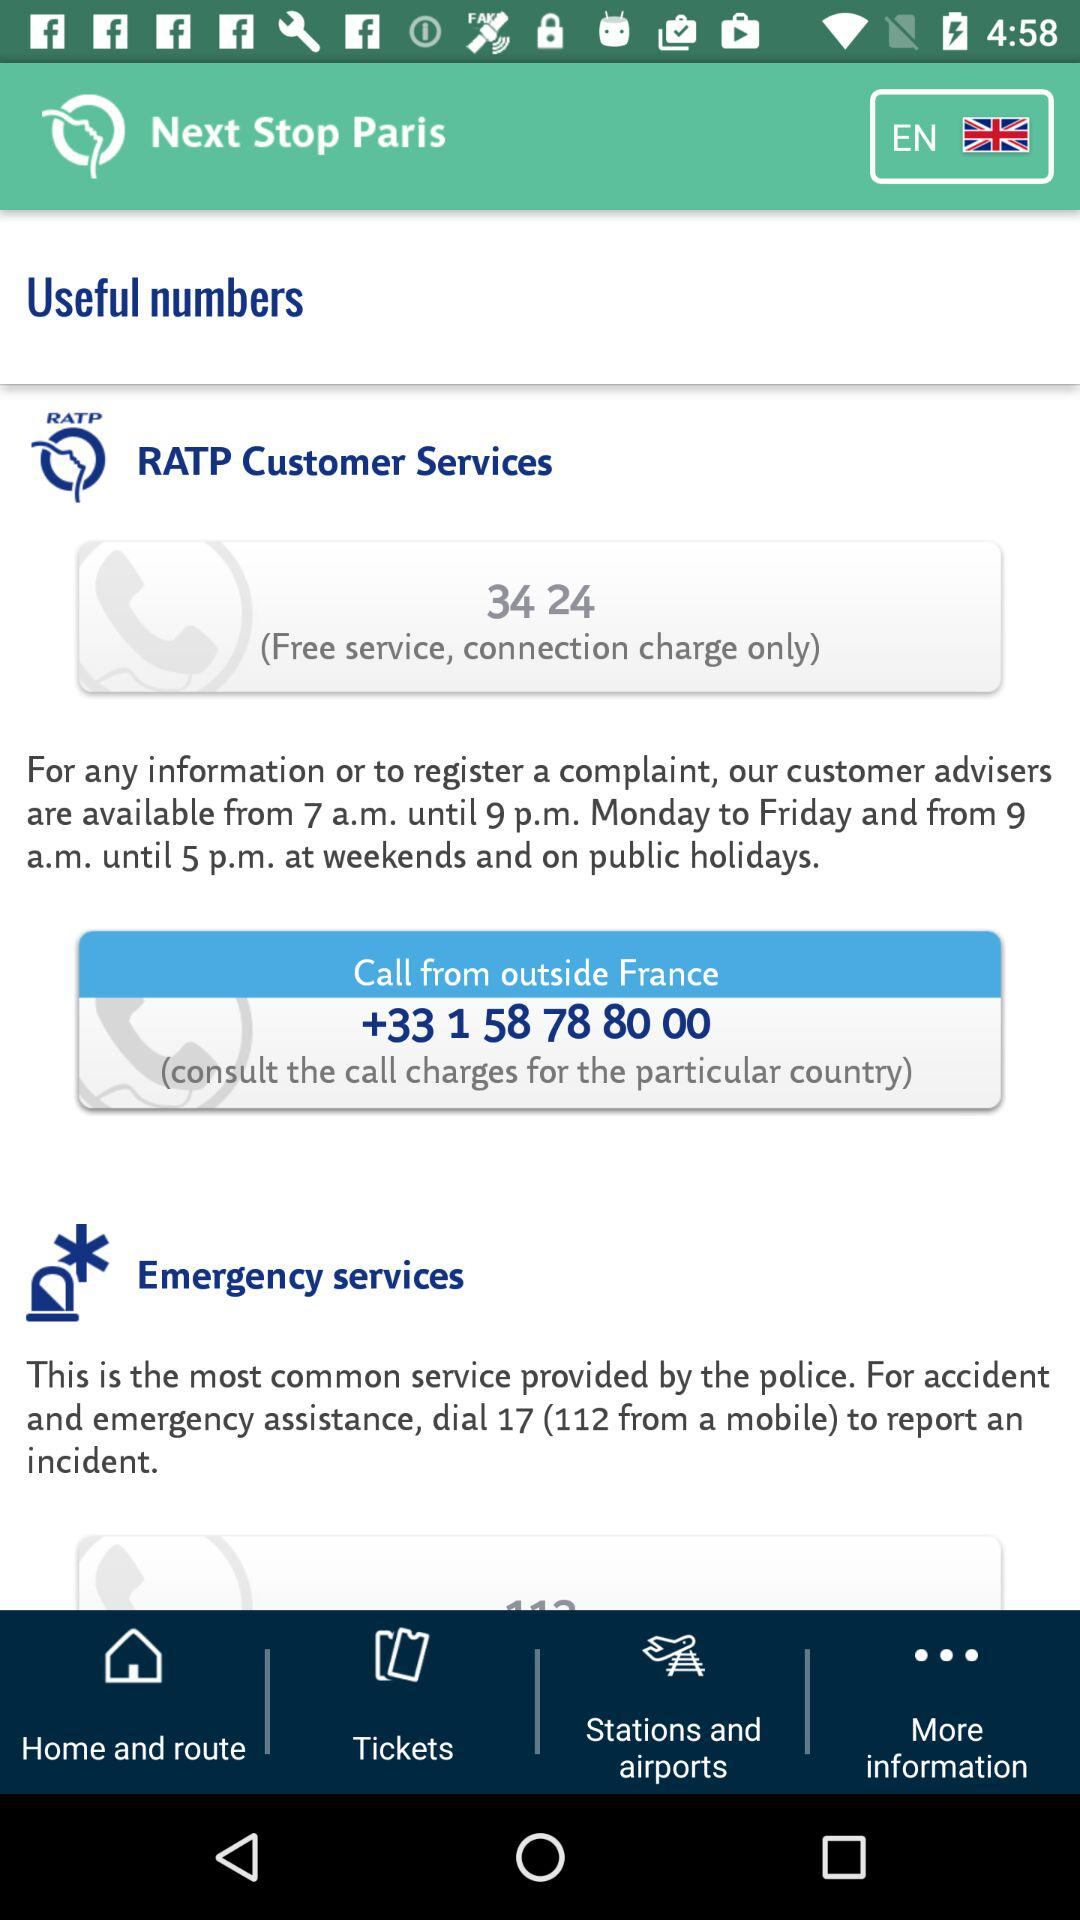What is the customer service number to call from outside France? The customer service number to call from outside France is +33 1 58 78 80 00. 